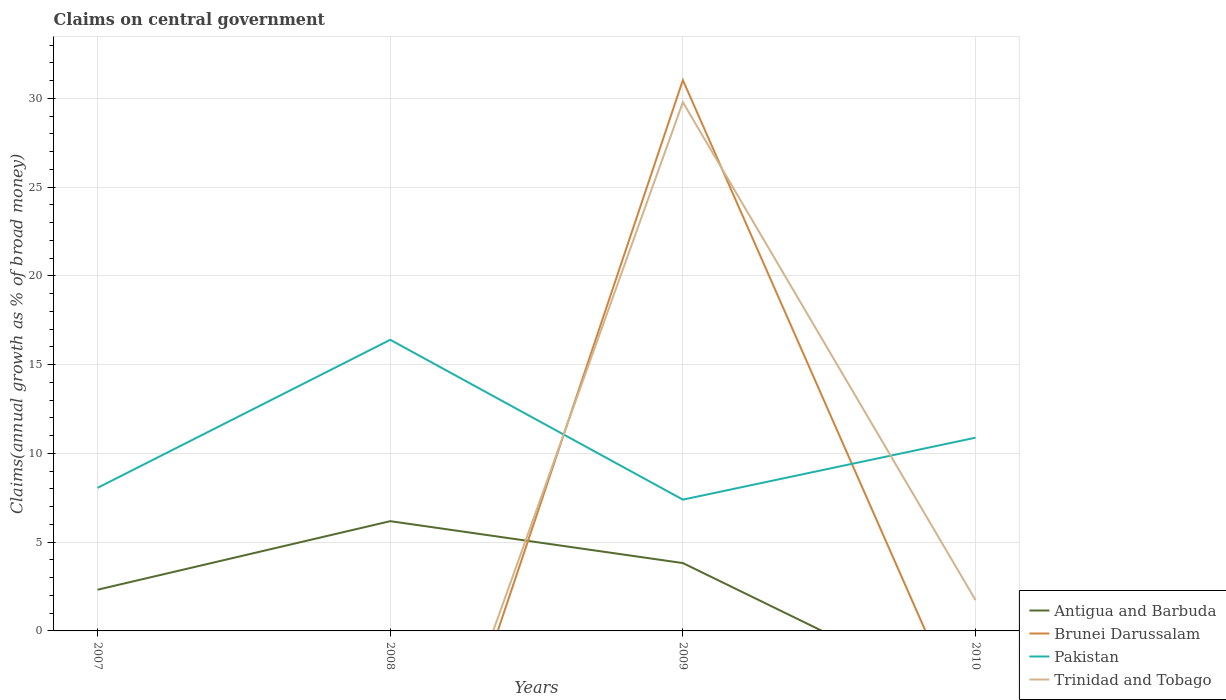How many different coloured lines are there?
Your answer should be very brief. 4. Is the number of lines equal to the number of legend labels?
Keep it short and to the point. No. What is the total percentage of broad money claimed on centeral government in Pakistan in the graph?
Keep it short and to the point. -8.34. What is the difference between the highest and the second highest percentage of broad money claimed on centeral government in Brunei Darussalam?
Offer a terse response. 31.03. What is the difference between the highest and the lowest percentage of broad money claimed on centeral government in Trinidad and Tobago?
Make the answer very short. 1. Is the percentage of broad money claimed on centeral government in Brunei Darussalam strictly greater than the percentage of broad money claimed on centeral government in Antigua and Barbuda over the years?
Ensure brevity in your answer.  No. How many years are there in the graph?
Your response must be concise. 4. What is the difference between two consecutive major ticks on the Y-axis?
Offer a very short reply. 5. Does the graph contain grids?
Keep it short and to the point. Yes. Where does the legend appear in the graph?
Provide a succinct answer. Bottom right. How are the legend labels stacked?
Provide a short and direct response. Vertical. What is the title of the graph?
Offer a very short reply. Claims on central government. Does "Djibouti" appear as one of the legend labels in the graph?
Ensure brevity in your answer.  No. What is the label or title of the Y-axis?
Give a very brief answer. Claims(annual growth as % of broad money). What is the Claims(annual growth as % of broad money) in Antigua and Barbuda in 2007?
Provide a short and direct response. 2.32. What is the Claims(annual growth as % of broad money) of Brunei Darussalam in 2007?
Offer a terse response. 0. What is the Claims(annual growth as % of broad money) in Pakistan in 2007?
Offer a very short reply. 8.06. What is the Claims(annual growth as % of broad money) in Antigua and Barbuda in 2008?
Offer a very short reply. 6.18. What is the Claims(annual growth as % of broad money) in Pakistan in 2008?
Your response must be concise. 16.4. What is the Claims(annual growth as % of broad money) in Trinidad and Tobago in 2008?
Provide a short and direct response. 0. What is the Claims(annual growth as % of broad money) in Antigua and Barbuda in 2009?
Your answer should be compact. 3.82. What is the Claims(annual growth as % of broad money) in Brunei Darussalam in 2009?
Offer a very short reply. 31.03. What is the Claims(annual growth as % of broad money) in Pakistan in 2009?
Provide a succinct answer. 7.4. What is the Claims(annual growth as % of broad money) in Trinidad and Tobago in 2009?
Offer a very short reply. 29.78. What is the Claims(annual growth as % of broad money) of Antigua and Barbuda in 2010?
Give a very brief answer. 0. What is the Claims(annual growth as % of broad money) of Brunei Darussalam in 2010?
Your response must be concise. 0. What is the Claims(annual growth as % of broad money) of Pakistan in 2010?
Ensure brevity in your answer.  10.88. What is the Claims(annual growth as % of broad money) in Trinidad and Tobago in 2010?
Provide a short and direct response. 1.74. Across all years, what is the maximum Claims(annual growth as % of broad money) of Antigua and Barbuda?
Provide a succinct answer. 6.18. Across all years, what is the maximum Claims(annual growth as % of broad money) in Brunei Darussalam?
Provide a succinct answer. 31.03. Across all years, what is the maximum Claims(annual growth as % of broad money) of Pakistan?
Offer a very short reply. 16.4. Across all years, what is the maximum Claims(annual growth as % of broad money) of Trinidad and Tobago?
Give a very brief answer. 29.78. Across all years, what is the minimum Claims(annual growth as % of broad money) of Antigua and Barbuda?
Your answer should be very brief. 0. Across all years, what is the minimum Claims(annual growth as % of broad money) of Pakistan?
Offer a terse response. 7.4. What is the total Claims(annual growth as % of broad money) in Antigua and Barbuda in the graph?
Offer a terse response. 12.33. What is the total Claims(annual growth as % of broad money) of Brunei Darussalam in the graph?
Keep it short and to the point. 31.03. What is the total Claims(annual growth as % of broad money) of Pakistan in the graph?
Provide a succinct answer. 42.74. What is the total Claims(annual growth as % of broad money) in Trinidad and Tobago in the graph?
Your answer should be very brief. 31.52. What is the difference between the Claims(annual growth as % of broad money) in Antigua and Barbuda in 2007 and that in 2008?
Your answer should be very brief. -3.86. What is the difference between the Claims(annual growth as % of broad money) of Pakistan in 2007 and that in 2008?
Keep it short and to the point. -8.34. What is the difference between the Claims(annual growth as % of broad money) in Antigua and Barbuda in 2007 and that in 2009?
Your answer should be compact. -1.5. What is the difference between the Claims(annual growth as % of broad money) in Pakistan in 2007 and that in 2009?
Make the answer very short. 0.67. What is the difference between the Claims(annual growth as % of broad money) of Pakistan in 2007 and that in 2010?
Offer a very short reply. -2.82. What is the difference between the Claims(annual growth as % of broad money) in Antigua and Barbuda in 2008 and that in 2009?
Provide a succinct answer. 2.36. What is the difference between the Claims(annual growth as % of broad money) of Pakistan in 2008 and that in 2009?
Offer a very short reply. 9. What is the difference between the Claims(annual growth as % of broad money) in Pakistan in 2008 and that in 2010?
Offer a very short reply. 5.51. What is the difference between the Claims(annual growth as % of broad money) in Pakistan in 2009 and that in 2010?
Your answer should be compact. -3.49. What is the difference between the Claims(annual growth as % of broad money) of Trinidad and Tobago in 2009 and that in 2010?
Offer a very short reply. 28.05. What is the difference between the Claims(annual growth as % of broad money) of Antigua and Barbuda in 2007 and the Claims(annual growth as % of broad money) of Pakistan in 2008?
Ensure brevity in your answer.  -14.08. What is the difference between the Claims(annual growth as % of broad money) of Antigua and Barbuda in 2007 and the Claims(annual growth as % of broad money) of Brunei Darussalam in 2009?
Keep it short and to the point. -28.71. What is the difference between the Claims(annual growth as % of broad money) of Antigua and Barbuda in 2007 and the Claims(annual growth as % of broad money) of Pakistan in 2009?
Ensure brevity in your answer.  -5.07. What is the difference between the Claims(annual growth as % of broad money) of Antigua and Barbuda in 2007 and the Claims(annual growth as % of broad money) of Trinidad and Tobago in 2009?
Offer a terse response. -27.46. What is the difference between the Claims(annual growth as % of broad money) in Pakistan in 2007 and the Claims(annual growth as % of broad money) in Trinidad and Tobago in 2009?
Provide a short and direct response. -21.72. What is the difference between the Claims(annual growth as % of broad money) in Antigua and Barbuda in 2007 and the Claims(annual growth as % of broad money) in Pakistan in 2010?
Offer a very short reply. -8.56. What is the difference between the Claims(annual growth as % of broad money) of Antigua and Barbuda in 2007 and the Claims(annual growth as % of broad money) of Trinidad and Tobago in 2010?
Offer a terse response. 0.59. What is the difference between the Claims(annual growth as % of broad money) of Pakistan in 2007 and the Claims(annual growth as % of broad money) of Trinidad and Tobago in 2010?
Make the answer very short. 6.32. What is the difference between the Claims(annual growth as % of broad money) of Antigua and Barbuda in 2008 and the Claims(annual growth as % of broad money) of Brunei Darussalam in 2009?
Offer a terse response. -24.84. What is the difference between the Claims(annual growth as % of broad money) of Antigua and Barbuda in 2008 and the Claims(annual growth as % of broad money) of Pakistan in 2009?
Your answer should be very brief. -1.21. What is the difference between the Claims(annual growth as % of broad money) of Antigua and Barbuda in 2008 and the Claims(annual growth as % of broad money) of Trinidad and Tobago in 2009?
Offer a terse response. -23.6. What is the difference between the Claims(annual growth as % of broad money) in Pakistan in 2008 and the Claims(annual growth as % of broad money) in Trinidad and Tobago in 2009?
Offer a terse response. -13.38. What is the difference between the Claims(annual growth as % of broad money) in Antigua and Barbuda in 2008 and the Claims(annual growth as % of broad money) in Pakistan in 2010?
Give a very brief answer. -4.7. What is the difference between the Claims(annual growth as % of broad money) in Antigua and Barbuda in 2008 and the Claims(annual growth as % of broad money) in Trinidad and Tobago in 2010?
Provide a short and direct response. 4.45. What is the difference between the Claims(annual growth as % of broad money) of Pakistan in 2008 and the Claims(annual growth as % of broad money) of Trinidad and Tobago in 2010?
Your answer should be compact. 14.66. What is the difference between the Claims(annual growth as % of broad money) of Antigua and Barbuda in 2009 and the Claims(annual growth as % of broad money) of Pakistan in 2010?
Your answer should be very brief. -7.06. What is the difference between the Claims(annual growth as % of broad money) of Antigua and Barbuda in 2009 and the Claims(annual growth as % of broad money) of Trinidad and Tobago in 2010?
Ensure brevity in your answer.  2.09. What is the difference between the Claims(annual growth as % of broad money) of Brunei Darussalam in 2009 and the Claims(annual growth as % of broad money) of Pakistan in 2010?
Offer a very short reply. 20.14. What is the difference between the Claims(annual growth as % of broad money) of Brunei Darussalam in 2009 and the Claims(annual growth as % of broad money) of Trinidad and Tobago in 2010?
Your answer should be very brief. 29.29. What is the difference between the Claims(annual growth as % of broad money) in Pakistan in 2009 and the Claims(annual growth as % of broad money) in Trinidad and Tobago in 2010?
Your response must be concise. 5.66. What is the average Claims(annual growth as % of broad money) of Antigua and Barbuda per year?
Your response must be concise. 3.08. What is the average Claims(annual growth as % of broad money) in Brunei Darussalam per year?
Offer a very short reply. 7.76. What is the average Claims(annual growth as % of broad money) of Pakistan per year?
Provide a short and direct response. 10.69. What is the average Claims(annual growth as % of broad money) in Trinidad and Tobago per year?
Offer a terse response. 7.88. In the year 2007, what is the difference between the Claims(annual growth as % of broad money) in Antigua and Barbuda and Claims(annual growth as % of broad money) in Pakistan?
Your response must be concise. -5.74. In the year 2008, what is the difference between the Claims(annual growth as % of broad money) in Antigua and Barbuda and Claims(annual growth as % of broad money) in Pakistan?
Offer a terse response. -10.22. In the year 2009, what is the difference between the Claims(annual growth as % of broad money) in Antigua and Barbuda and Claims(annual growth as % of broad money) in Brunei Darussalam?
Your response must be concise. -27.21. In the year 2009, what is the difference between the Claims(annual growth as % of broad money) in Antigua and Barbuda and Claims(annual growth as % of broad money) in Pakistan?
Ensure brevity in your answer.  -3.57. In the year 2009, what is the difference between the Claims(annual growth as % of broad money) in Antigua and Barbuda and Claims(annual growth as % of broad money) in Trinidad and Tobago?
Make the answer very short. -25.96. In the year 2009, what is the difference between the Claims(annual growth as % of broad money) in Brunei Darussalam and Claims(annual growth as % of broad money) in Pakistan?
Give a very brief answer. 23.63. In the year 2009, what is the difference between the Claims(annual growth as % of broad money) in Brunei Darussalam and Claims(annual growth as % of broad money) in Trinidad and Tobago?
Give a very brief answer. 1.24. In the year 2009, what is the difference between the Claims(annual growth as % of broad money) in Pakistan and Claims(annual growth as % of broad money) in Trinidad and Tobago?
Keep it short and to the point. -22.39. In the year 2010, what is the difference between the Claims(annual growth as % of broad money) in Pakistan and Claims(annual growth as % of broad money) in Trinidad and Tobago?
Provide a short and direct response. 9.15. What is the ratio of the Claims(annual growth as % of broad money) in Antigua and Barbuda in 2007 to that in 2008?
Offer a terse response. 0.38. What is the ratio of the Claims(annual growth as % of broad money) of Pakistan in 2007 to that in 2008?
Keep it short and to the point. 0.49. What is the ratio of the Claims(annual growth as % of broad money) in Antigua and Barbuda in 2007 to that in 2009?
Offer a terse response. 0.61. What is the ratio of the Claims(annual growth as % of broad money) in Pakistan in 2007 to that in 2009?
Offer a very short reply. 1.09. What is the ratio of the Claims(annual growth as % of broad money) of Pakistan in 2007 to that in 2010?
Provide a short and direct response. 0.74. What is the ratio of the Claims(annual growth as % of broad money) of Antigua and Barbuda in 2008 to that in 2009?
Offer a terse response. 1.62. What is the ratio of the Claims(annual growth as % of broad money) in Pakistan in 2008 to that in 2009?
Provide a short and direct response. 2.22. What is the ratio of the Claims(annual growth as % of broad money) of Pakistan in 2008 to that in 2010?
Keep it short and to the point. 1.51. What is the ratio of the Claims(annual growth as % of broad money) of Pakistan in 2009 to that in 2010?
Offer a terse response. 0.68. What is the ratio of the Claims(annual growth as % of broad money) of Trinidad and Tobago in 2009 to that in 2010?
Ensure brevity in your answer.  17.15. What is the difference between the highest and the second highest Claims(annual growth as % of broad money) of Antigua and Barbuda?
Your response must be concise. 2.36. What is the difference between the highest and the second highest Claims(annual growth as % of broad money) in Pakistan?
Offer a very short reply. 5.51. What is the difference between the highest and the lowest Claims(annual growth as % of broad money) of Antigua and Barbuda?
Make the answer very short. 6.18. What is the difference between the highest and the lowest Claims(annual growth as % of broad money) of Brunei Darussalam?
Provide a succinct answer. 31.03. What is the difference between the highest and the lowest Claims(annual growth as % of broad money) in Pakistan?
Offer a terse response. 9. What is the difference between the highest and the lowest Claims(annual growth as % of broad money) of Trinidad and Tobago?
Ensure brevity in your answer.  29.78. 